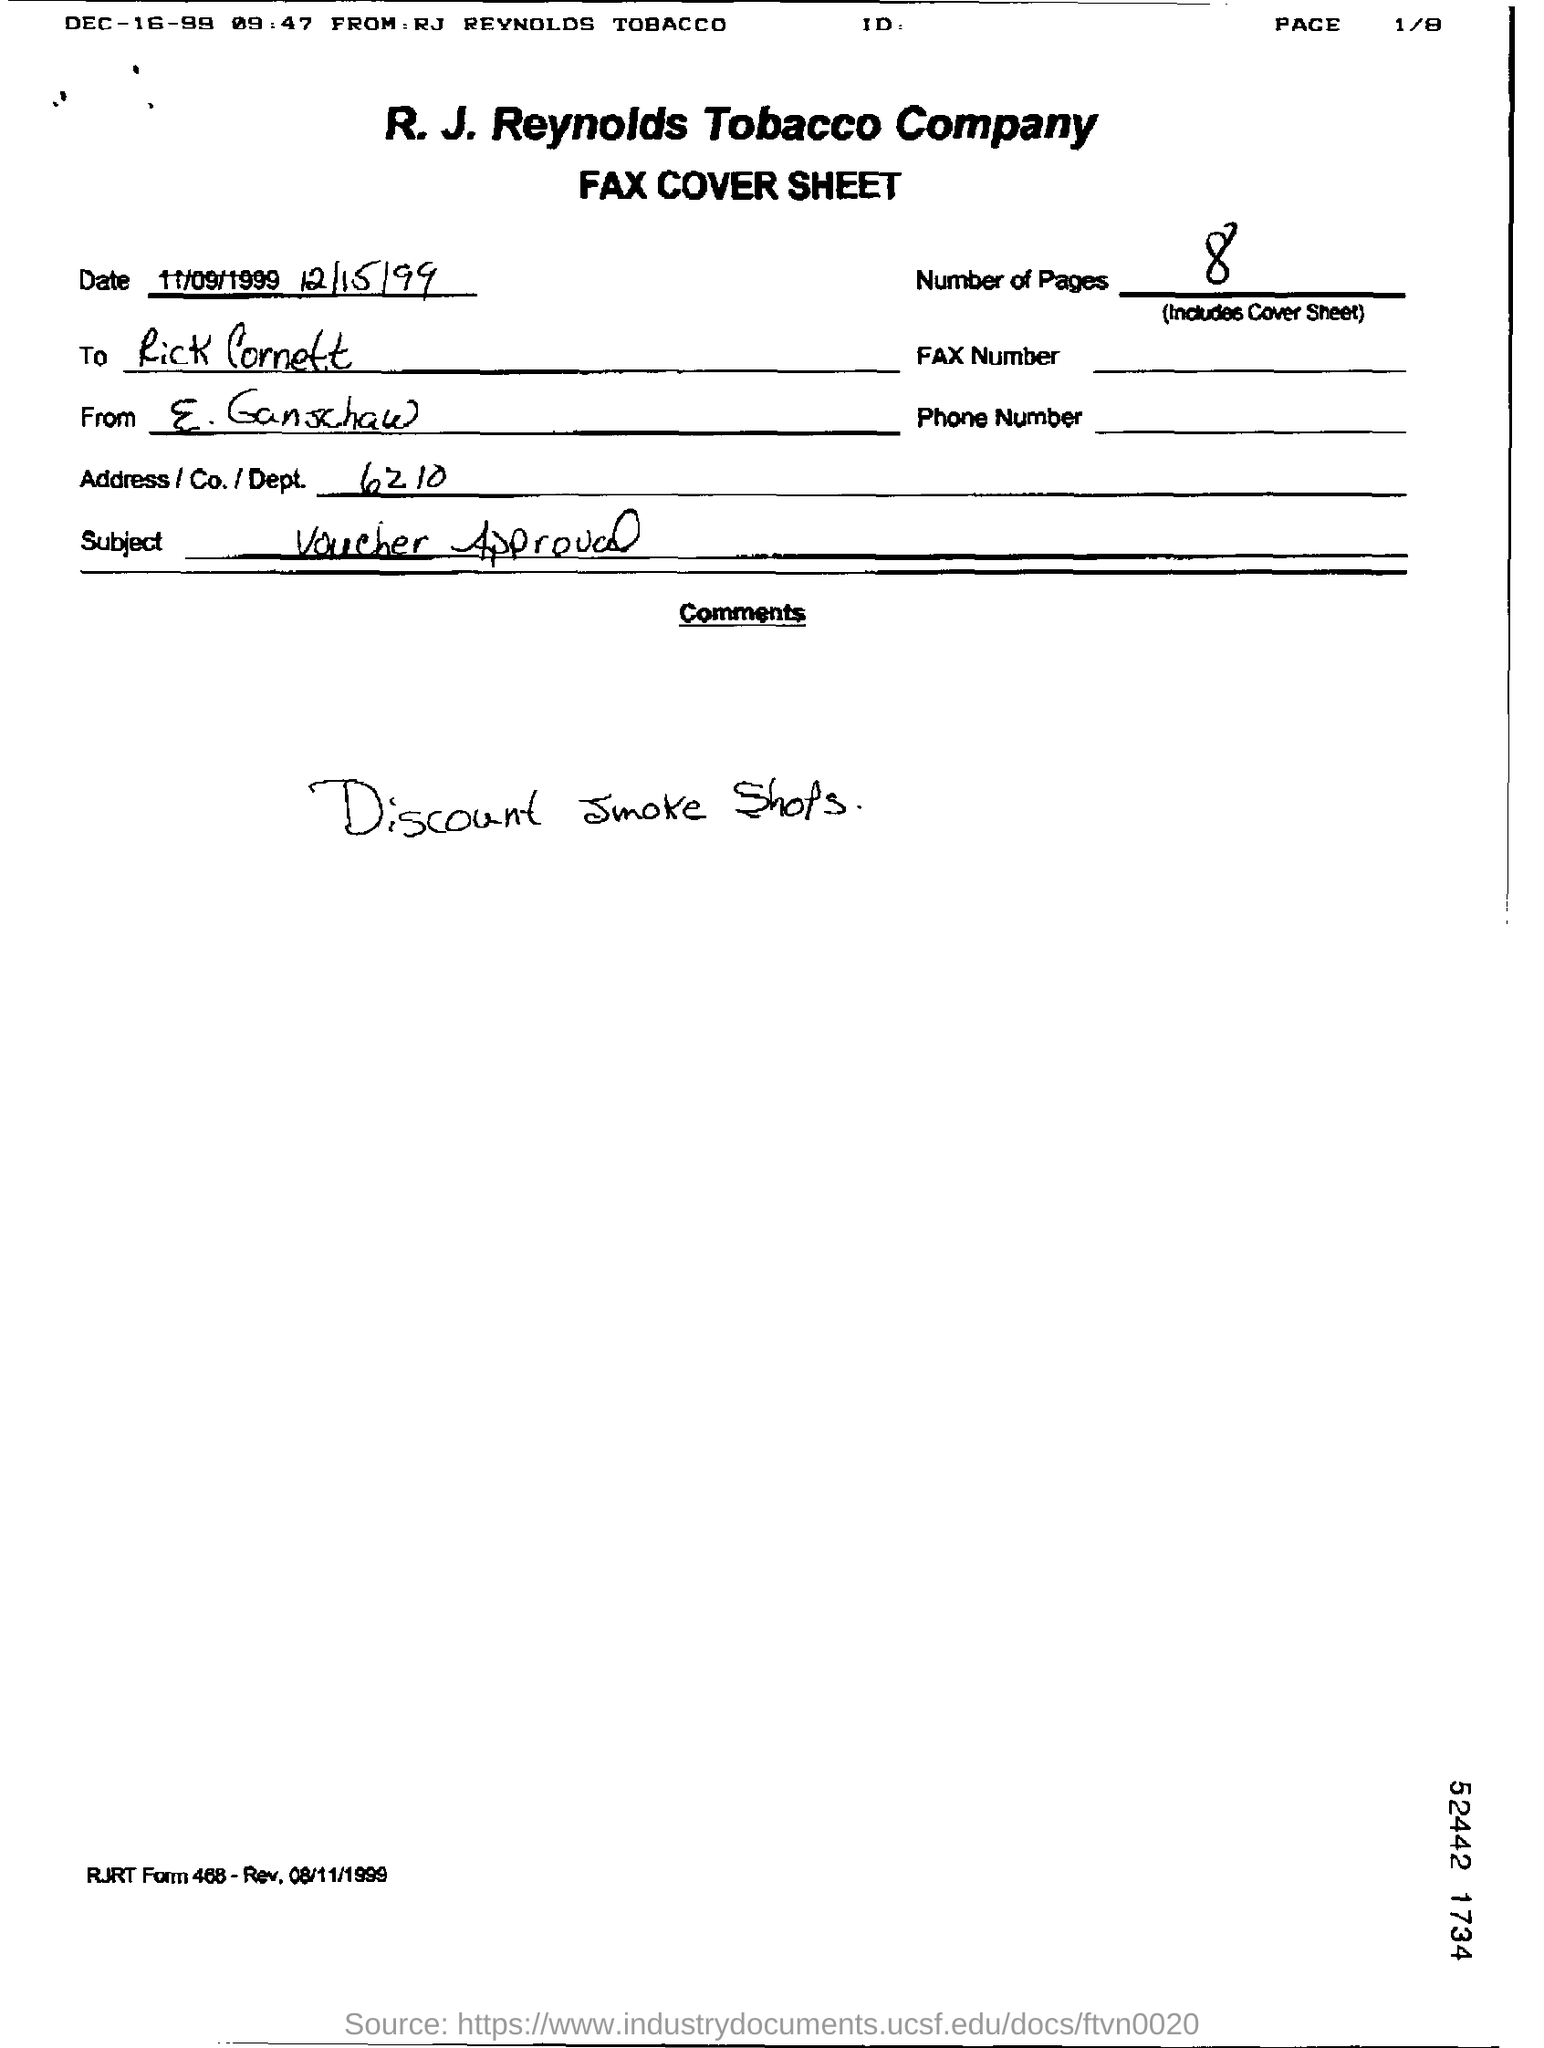Indicate a few pertinent items in this graphic. The subject is the Voucher Approval. There are 8 pages in total. The person being referred to is E. Ganschaw. The address is 6210, followed by the company and department. 